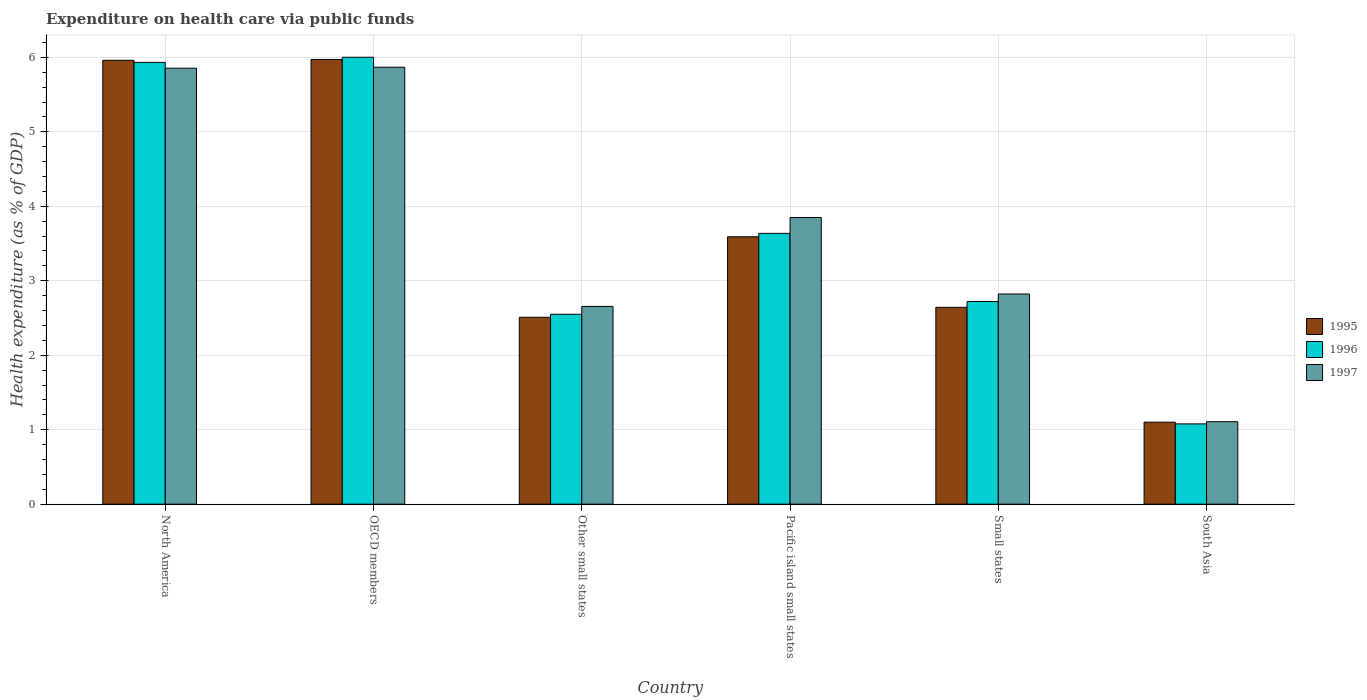How many different coloured bars are there?
Ensure brevity in your answer.  3. How many bars are there on the 3rd tick from the left?
Your response must be concise. 3. How many bars are there on the 5th tick from the right?
Your answer should be very brief. 3. What is the label of the 3rd group of bars from the left?
Give a very brief answer. Other small states. What is the expenditure made on health care in 1996 in OECD members?
Provide a short and direct response. 6. Across all countries, what is the maximum expenditure made on health care in 1996?
Keep it short and to the point. 6. Across all countries, what is the minimum expenditure made on health care in 1996?
Your answer should be compact. 1.08. In which country was the expenditure made on health care in 1997 minimum?
Your answer should be very brief. South Asia. What is the total expenditure made on health care in 1996 in the graph?
Your answer should be compact. 21.92. What is the difference between the expenditure made on health care in 1995 in OECD members and that in Small states?
Provide a succinct answer. 3.33. What is the difference between the expenditure made on health care in 1995 in North America and the expenditure made on health care in 1997 in OECD members?
Keep it short and to the point. 0.09. What is the average expenditure made on health care in 1995 per country?
Offer a very short reply. 3.63. What is the difference between the expenditure made on health care of/in 1997 and expenditure made on health care of/in 1996 in Pacific island small states?
Offer a very short reply. 0.21. What is the ratio of the expenditure made on health care in 1995 in North America to that in South Asia?
Ensure brevity in your answer.  5.41. Is the expenditure made on health care in 1995 in OECD members less than that in Small states?
Make the answer very short. No. What is the difference between the highest and the second highest expenditure made on health care in 1997?
Your answer should be very brief. 2. What is the difference between the highest and the lowest expenditure made on health care in 1997?
Provide a short and direct response. 4.76. Is it the case that in every country, the sum of the expenditure made on health care in 1997 and expenditure made on health care in 1995 is greater than the expenditure made on health care in 1996?
Keep it short and to the point. Yes. How many bars are there?
Give a very brief answer. 18. What is the difference between two consecutive major ticks on the Y-axis?
Keep it short and to the point. 1. How many legend labels are there?
Offer a terse response. 3. How are the legend labels stacked?
Your answer should be compact. Vertical. What is the title of the graph?
Provide a short and direct response. Expenditure on health care via public funds. What is the label or title of the Y-axis?
Offer a terse response. Health expenditure (as % of GDP). What is the Health expenditure (as % of GDP) in 1995 in North America?
Keep it short and to the point. 5.96. What is the Health expenditure (as % of GDP) of 1996 in North America?
Provide a succinct answer. 5.93. What is the Health expenditure (as % of GDP) of 1997 in North America?
Give a very brief answer. 5.85. What is the Health expenditure (as % of GDP) of 1995 in OECD members?
Offer a terse response. 5.97. What is the Health expenditure (as % of GDP) of 1996 in OECD members?
Offer a very short reply. 6. What is the Health expenditure (as % of GDP) in 1997 in OECD members?
Offer a very short reply. 5.87. What is the Health expenditure (as % of GDP) of 1995 in Other small states?
Ensure brevity in your answer.  2.51. What is the Health expenditure (as % of GDP) in 1996 in Other small states?
Make the answer very short. 2.55. What is the Health expenditure (as % of GDP) in 1997 in Other small states?
Offer a terse response. 2.66. What is the Health expenditure (as % of GDP) in 1995 in Pacific island small states?
Your answer should be compact. 3.59. What is the Health expenditure (as % of GDP) in 1996 in Pacific island small states?
Keep it short and to the point. 3.64. What is the Health expenditure (as % of GDP) of 1997 in Pacific island small states?
Give a very brief answer. 3.85. What is the Health expenditure (as % of GDP) in 1995 in Small states?
Give a very brief answer. 2.64. What is the Health expenditure (as % of GDP) in 1996 in Small states?
Make the answer very short. 2.72. What is the Health expenditure (as % of GDP) in 1997 in Small states?
Your answer should be very brief. 2.82. What is the Health expenditure (as % of GDP) in 1995 in South Asia?
Provide a succinct answer. 1.1. What is the Health expenditure (as % of GDP) in 1996 in South Asia?
Keep it short and to the point. 1.08. What is the Health expenditure (as % of GDP) of 1997 in South Asia?
Ensure brevity in your answer.  1.11. Across all countries, what is the maximum Health expenditure (as % of GDP) in 1995?
Make the answer very short. 5.97. Across all countries, what is the maximum Health expenditure (as % of GDP) in 1996?
Give a very brief answer. 6. Across all countries, what is the maximum Health expenditure (as % of GDP) of 1997?
Your response must be concise. 5.87. Across all countries, what is the minimum Health expenditure (as % of GDP) of 1995?
Keep it short and to the point. 1.1. Across all countries, what is the minimum Health expenditure (as % of GDP) of 1996?
Give a very brief answer. 1.08. Across all countries, what is the minimum Health expenditure (as % of GDP) of 1997?
Offer a very short reply. 1.11. What is the total Health expenditure (as % of GDP) of 1995 in the graph?
Your answer should be very brief. 21.78. What is the total Health expenditure (as % of GDP) of 1996 in the graph?
Provide a succinct answer. 21.92. What is the total Health expenditure (as % of GDP) of 1997 in the graph?
Provide a succinct answer. 22.16. What is the difference between the Health expenditure (as % of GDP) in 1995 in North America and that in OECD members?
Make the answer very short. -0.01. What is the difference between the Health expenditure (as % of GDP) of 1996 in North America and that in OECD members?
Provide a succinct answer. -0.07. What is the difference between the Health expenditure (as % of GDP) in 1997 in North America and that in OECD members?
Your response must be concise. -0.01. What is the difference between the Health expenditure (as % of GDP) in 1995 in North America and that in Other small states?
Make the answer very short. 3.45. What is the difference between the Health expenditure (as % of GDP) of 1996 in North America and that in Other small states?
Your answer should be very brief. 3.38. What is the difference between the Health expenditure (as % of GDP) in 1997 in North America and that in Other small states?
Your answer should be compact. 3.2. What is the difference between the Health expenditure (as % of GDP) of 1995 in North America and that in Pacific island small states?
Give a very brief answer. 2.37. What is the difference between the Health expenditure (as % of GDP) of 1996 in North America and that in Pacific island small states?
Your response must be concise. 2.3. What is the difference between the Health expenditure (as % of GDP) of 1997 in North America and that in Pacific island small states?
Offer a very short reply. 2. What is the difference between the Health expenditure (as % of GDP) of 1995 in North America and that in Small states?
Offer a very short reply. 3.32. What is the difference between the Health expenditure (as % of GDP) of 1996 in North America and that in Small states?
Offer a very short reply. 3.21. What is the difference between the Health expenditure (as % of GDP) of 1997 in North America and that in Small states?
Give a very brief answer. 3.03. What is the difference between the Health expenditure (as % of GDP) in 1995 in North America and that in South Asia?
Provide a short and direct response. 4.86. What is the difference between the Health expenditure (as % of GDP) of 1996 in North America and that in South Asia?
Provide a short and direct response. 4.85. What is the difference between the Health expenditure (as % of GDP) of 1997 in North America and that in South Asia?
Your response must be concise. 4.75. What is the difference between the Health expenditure (as % of GDP) of 1995 in OECD members and that in Other small states?
Offer a terse response. 3.46. What is the difference between the Health expenditure (as % of GDP) in 1996 in OECD members and that in Other small states?
Your response must be concise. 3.45. What is the difference between the Health expenditure (as % of GDP) of 1997 in OECD members and that in Other small states?
Offer a terse response. 3.21. What is the difference between the Health expenditure (as % of GDP) in 1995 in OECD members and that in Pacific island small states?
Your answer should be very brief. 2.38. What is the difference between the Health expenditure (as % of GDP) in 1996 in OECD members and that in Pacific island small states?
Ensure brevity in your answer.  2.37. What is the difference between the Health expenditure (as % of GDP) of 1997 in OECD members and that in Pacific island small states?
Keep it short and to the point. 2.02. What is the difference between the Health expenditure (as % of GDP) in 1995 in OECD members and that in Small states?
Your response must be concise. 3.33. What is the difference between the Health expenditure (as % of GDP) in 1996 in OECD members and that in Small states?
Your answer should be very brief. 3.28. What is the difference between the Health expenditure (as % of GDP) of 1997 in OECD members and that in Small states?
Ensure brevity in your answer.  3.05. What is the difference between the Health expenditure (as % of GDP) of 1995 in OECD members and that in South Asia?
Provide a succinct answer. 4.87. What is the difference between the Health expenditure (as % of GDP) in 1996 in OECD members and that in South Asia?
Offer a terse response. 4.92. What is the difference between the Health expenditure (as % of GDP) of 1997 in OECD members and that in South Asia?
Your response must be concise. 4.76. What is the difference between the Health expenditure (as % of GDP) in 1995 in Other small states and that in Pacific island small states?
Offer a terse response. -1.08. What is the difference between the Health expenditure (as % of GDP) in 1996 in Other small states and that in Pacific island small states?
Your answer should be compact. -1.09. What is the difference between the Health expenditure (as % of GDP) in 1997 in Other small states and that in Pacific island small states?
Offer a very short reply. -1.19. What is the difference between the Health expenditure (as % of GDP) in 1995 in Other small states and that in Small states?
Your answer should be very brief. -0.13. What is the difference between the Health expenditure (as % of GDP) in 1996 in Other small states and that in Small states?
Offer a terse response. -0.17. What is the difference between the Health expenditure (as % of GDP) in 1997 in Other small states and that in Small states?
Keep it short and to the point. -0.17. What is the difference between the Health expenditure (as % of GDP) in 1995 in Other small states and that in South Asia?
Your answer should be very brief. 1.41. What is the difference between the Health expenditure (as % of GDP) in 1996 in Other small states and that in South Asia?
Offer a very short reply. 1.47. What is the difference between the Health expenditure (as % of GDP) of 1997 in Other small states and that in South Asia?
Offer a terse response. 1.55. What is the difference between the Health expenditure (as % of GDP) in 1995 in Pacific island small states and that in Small states?
Your answer should be very brief. 0.95. What is the difference between the Health expenditure (as % of GDP) of 1996 in Pacific island small states and that in Small states?
Offer a very short reply. 0.92. What is the difference between the Health expenditure (as % of GDP) of 1997 in Pacific island small states and that in Small states?
Your response must be concise. 1.03. What is the difference between the Health expenditure (as % of GDP) in 1995 in Pacific island small states and that in South Asia?
Your answer should be compact. 2.49. What is the difference between the Health expenditure (as % of GDP) in 1996 in Pacific island small states and that in South Asia?
Your answer should be compact. 2.56. What is the difference between the Health expenditure (as % of GDP) of 1997 in Pacific island small states and that in South Asia?
Offer a very short reply. 2.74. What is the difference between the Health expenditure (as % of GDP) in 1995 in Small states and that in South Asia?
Your answer should be very brief. 1.54. What is the difference between the Health expenditure (as % of GDP) in 1996 in Small states and that in South Asia?
Offer a very short reply. 1.64. What is the difference between the Health expenditure (as % of GDP) in 1997 in Small states and that in South Asia?
Make the answer very short. 1.71. What is the difference between the Health expenditure (as % of GDP) in 1995 in North America and the Health expenditure (as % of GDP) in 1996 in OECD members?
Your response must be concise. -0.04. What is the difference between the Health expenditure (as % of GDP) of 1995 in North America and the Health expenditure (as % of GDP) of 1997 in OECD members?
Your response must be concise. 0.09. What is the difference between the Health expenditure (as % of GDP) of 1996 in North America and the Health expenditure (as % of GDP) of 1997 in OECD members?
Offer a terse response. 0.06. What is the difference between the Health expenditure (as % of GDP) of 1995 in North America and the Health expenditure (as % of GDP) of 1996 in Other small states?
Offer a very short reply. 3.41. What is the difference between the Health expenditure (as % of GDP) in 1995 in North America and the Health expenditure (as % of GDP) in 1997 in Other small states?
Your answer should be compact. 3.31. What is the difference between the Health expenditure (as % of GDP) in 1996 in North America and the Health expenditure (as % of GDP) in 1997 in Other small states?
Give a very brief answer. 3.28. What is the difference between the Health expenditure (as % of GDP) of 1995 in North America and the Health expenditure (as % of GDP) of 1996 in Pacific island small states?
Provide a succinct answer. 2.32. What is the difference between the Health expenditure (as % of GDP) in 1995 in North America and the Health expenditure (as % of GDP) in 1997 in Pacific island small states?
Give a very brief answer. 2.11. What is the difference between the Health expenditure (as % of GDP) of 1996 in North America and the Health expenditure (as % of GDP) of 1997 in Pacific island small states?
Offer a very short reply. 2.08. What is the difference between the Health expenditure (as % of GDP) of 1995 in North America and the Health expenditure (as % of GDP) of 1996 in Small states?
Offer a very short reply. 3.24. What is the difference between the Health expenditure (as % of GDP) of 1995 in North America and the Health expenditure (as % of GDP) of 1997 in Small states?
Offer a very short reply. 3.14. What is the difference between the Health expenditure (as % of GDP) of 1996 in North America and the Health expenditure (as % of GDP) of 1997 in Small states?
Your answer should be very brief. 3.11. What is the difference between the Health expenditure (as % of GDP) of 1995 in North America and the Health expenditure (as % of GDP) of 1996 in South Asia?
Your answer should be very brief. 4.88. What is the difference between the Health expenditure (as % of GDP) in 1995 in North America and the Health expenditure (as % of GDP) in 1997 in South Asia?
Provide a short and direct response. 4.85. What is the difference between the Health expenditure (as % of GDP) in 1996 in North America and the Health expenditure (as % of GDP) in 1997 in South Asia?
Keep it short and to the point. 4.83. What is the difference between the Health expenditure (as % of GDP) of 1995 in OECD members and the Health expenditure (as % of GDP) of 1996 in Other small states?
Your answer should be compact. 3.42. What is the difference between the Health expenditure (as % of GDP) of 1995 in OECD members and the Health expenditure (as % of GDP) of 1997 in Other small states?
Your response must be concise. 3.32. What is the difference between the Health expenditure (as % of GDP) in 1996 in OECD members and the Health expenditure (as % of GDP) in 1997 in Other small states?
Your answer should be compact. 3.35. What is the difference between the Health expenditure (as % of GDP) of 1995 in OECD members and the Health expenditure (as % of GDP) of 1996 in Pacific island small states?
Your response must be concise. 2.34. What is the difference between the Health expenditure (as % of GDP) of 1995 in OECD members and the Health expenditure (as % of GDP) of 1997 in Pacific island small states?
Your response must be concise. 2.12. What is the difference between the Health expenditure (as % of GDP) of 1996 in OECD members and the Health expenditure (as % of GDP) of 1997 in Pacific island small states?
Provide a succinct answer. 2.15. What is the difference between the Health expenditure (as % of GDP) of 1995 in OECD members and the Health expenditure (as % of GDP) of 1996 in Small states?
Your answer should be compact. 3.25. What is the difference between the Health expenditure (as % of GDP) in 1995 in OECD members and the Health expenditure (as % of GDP) in 1997 in Small states?
Make the answer very short. 3.15. What is the difference between the Health expenditure (as % of GDP) in 1996 in OECD members and the Health expenditure (as % of GDP) in 1997 in Small states?
Your answer should be very brief. 3.18. What is the difference between the Health expenditure (as % of GDP) of 1995 in OECD members and the Health expenditure (as % of GDP) of 1996 in South Asia?
Offer a terse response. 4.89. What is the difference between the Health expenditure (as % of GDP) of 1995 in OECD members and the Health expenditure (as % of GDP) of 1997 in South Asia?
Provide a short and direct response. 4.86. What is the difference between the Health expenditure (as % of GDP) of 1996 in OECD members and the Health expenditure (as % of GDP) of 1997 in South Asia?
Keep it short and to the point. 4.89. What is the difference between the Health expenditure (as % of GDP) in 1995 in Other small states and the Health expenditure (as % of GDP) in 1996 in Pacific island small states?
Offer a terse response. -1.13. What is the difference between the Health expenditure (as % of GDP) in 1995 in Other small states and the Health expenditure (as % of GDP) in 1997 in Pacific island small states?
Offer a very short reply. -1.34. What is the difference between the Health expenditure (as % of GDP) of 1996 in Other small states and the Health expenditure (as % of GDP) of 1997 in Pacific island small states?
Provide a short and direct response. -1.3. What is the difference between the Health expenditure (as % of GDP) of 1995 in Other small states and the Health expenditure (as % of GDP) of 1996 in Small states?
Your answer should be compact. -0.21. What is the difference between the Health expenditure (as % of GDP) in 1995 in Other small states and the Health expenditure (as % of GDP) in 1997 in Small states?
Offer a very short reply. -0.31. What is the difference between the Health expenditure (as % of GDP) in 1996 in Other small states and the Health expenditure (as % of GDP) in 1997 in Small states?
Your answer should be very brief. -0.27. What is the difference between the Health expenditure (as % of GDP) of 1995 in Other small states and the Health expenditure (as % of GDP) of 1996 in South Asia?
Your response must be concise. 1.43. What is the difference between the Health expenditure (as % of GDP) of 1995 in Other small states and the Health expenditure (as % of GDP) of 1997 in South Asia?
Provide a short and direct response. 1.4. What is the difference between the Health expenditure (as % of GDP) of 1996 in Other small states and the Health expenditure (as % of GDP) of 1997 in South Asia?
Your response must be concise. 1.44. What is the difference between the Health expenditure (as % of GDP) in 1995 in Pacific island small states and the Health expenditure (as % of GDP) in 1996 in Small states?
Keep it short and to the point. 0.87. What is the difference between the Health expenditure (as % of GDP) of 1995 in Pacific island small states and the Health expenditure (as % of GDP) of 1997 in Small states?
Give a very brief answer. 0.77. What is the difference between the Health expenditure (as % of GDP) of 1996 in Pacific island small states and the Health expenditure (as % of GDP) of 1997 in Small states?
Your answer should be compact. 0.81. What is the difference between the Health expenditure (as % of GDP) in 1995 in Pacific island small states and the Health expenditure (as % of GDP) in 1996 in South Asia?
Provide a short and direct response. 2.51. What is the difference between the Health expenditure (as % of GDP) in 1995 in Pacific island small states and the Health expenditure (as % of GDP) in 1997 in South Asia?
Your answer should be very brief. 2.48. What is the difference between the Health expenditure (as % of GDP) of 1996 in Pacific island small states and the Health expenditure (as % of GDP) of 1997 in South Asia?
Offer a terse response. 2.53. What is the difference between the Health expenditure (as % of GDP) in 1995 in Small states and the Health expenditure (as % of GDP) in 1996 in South Asia?
Provide a succinct answer. 1.57. What is the difference between the Health expenditure (as % of GDP) in 1995 in Small states and the Health expenditure (as % of GDP) in 1997 in South Asia?
Your answer should be very brief. 1.54. What is the difference between the Health expenditure (as % of GDP) of 1996 in Small states and the Health expenditure (as % of GDP) of 1997 in South Asia?
Ensure brevity in your answer.  1.61. What is the average Health expenditure (as % of GDP) of 1995 per country?
Provide a succinct answer. 3.63. What is the average Health expenditure (as % of GDP) of 1996 per country?
Give a very brief answer. 3.65. What is the average Health expenditure (as % of GDP) of 1997 per country?
Provide a succinct answer. 3.69. What is the difference between the Health expenditure (as % of GDP) in 1995 and Health expenditure (as % of GDP) in 1996 in North America?
Provide a short and direct response. 0.03. What is the difference between the Health expenditure (as % of GDP) in 1995 and Health expenditure (as % of GDP) in 1997 in North America?
Provide a succinct answer. 0.11. What is the difference between the Health expenditure (as % of GDP) of 1996 and Health expenditure (as % of GDP) of 1997 in North America?
Give a very brief answer. 0.08. What is the difference between the Health expenditure (as % of GDP) of 1995 and Health expenditure (as % of GDP) of 1996 in OECD members?
Your answer should be very brief. -0.03. What is the difference between the Health expenditure (as % of GDP) in 1995 and Health expenditure (as % of GDP) in 1997 in OECD members?
Ensure brevity in your answer.  0.1. What is the difference between the Health expenditure (as % of GDP) of 1996 and Health expenditure (as % of GDP) of 1997 in OECD members?
Keep it short and to the point. 0.13. What is the difference between the Health expenditure (as % of GDP) in 1995 and Health expenditure (as % of GDP) in 1996 in Other small states?
Your answer should be very brief. -0.04. What is the difference between the Health expenditure (as % of GDP) of 1995 and Health expenditure (as % of GDP) of 1997 in Other small states?
Your answer should be compact. -0.15. What is the difference between the Health expenditure (as % of GDP) of 1996 and Health expenditure (as % of GDP) of 1997 in Other small states?
Provide a short and direct response. -0.11. What is the difference between the Health expenditure (as % of GDP) of 1995 and Health expenditure (as % of GDP) of 1996 in Pacific island small states?
Your answer should be compact. -0.05. What is the difference between the Health expenditure (as % of GDP) in 1995 and Health expenditure (as % of GDP) in 1997 in Pacific island small states?
Provide a succinct answer. -0.26. What is the difference between the Health expenditure (as % of GDP) in 1996 and Health expenditure (as % of GDP) in 1997 in Pacific island small states?
Ensure brevity in your answer.  -0.21. What is the difference between the Health expenditure (as % of GDP) in 1995 and Health expenditure (as % of GDP) in 1996 in Small states?
Ensure brevity in your answer.  -0.08. What is the difference between the Health expenditure (as % of GDP) in 1995 and Health expenditure (as % of GDP) in 1997 in Small states?
Your answer should be compact. -0.18. What is the difference between the Health expenditure (as % of GDP) in 1996 and Health expenditure (as % of GDP) in 1997 in Small states?
Ensure brevity in your answer.  -0.1. What is the difference between the Health expenditure (as % of GDP) in 1995 and Health expenditure (as % of GDP) in 1996 in South Asia?
Your answer should be compact. 0.02. What is the difference between the Health expenditure (as % of GDP) of 1995 and Health expenditure (as % of GDP) of 1997 in South Asia?
Keep it short and to the point. -0.01. What is the difference between the Health expenditure (as % of GDP) in 1996 and Health expenditure (as % of GDP) in 1997 in South Asia?
Give a very brief answer. -0.03. What is the ratio of the Health expenditure (as % of GDP) of 1996 in North America to that in OECD members?
Your answer should be very brief. 0.99. What is the ratio of the Health expenditure (as % of GDP) in 1997 in North America to that in OECD members?
Offer a very short reply. 1. What is the ratio of the Health expenditure (as % of GDP) in 1995 in North America to that in Other small states?
Make the answer very short. 2.38. What is the ratio of the Health expenditure (as % of GDP) in 1996 in North America to that in Other small states?
Give a very brief answer. 2.33. What is the ratio of the Health expenditure (as % of GDP) in 1997 in North America to that in Other small states?
Provide a succinct answer. 2.2. What is the ratio of the Health expenditure (as % of GDP) in 1995 in North America to that in Pacific island small states?
Provide a succinct answer. 1.66. What is the ratio of the Health expenditure (as % of GDP) in 1996 in North America to that in Pacific island small states?
Provide a short and direct response. 1.63. What is the ratio of the Health expenditure (as % of GDP) in 1997 in North America to that in Pacific island small states?
Keep it short and to the point. 1.52. What is the ratio of the Health expenditure (as % of GDP) of 1995 in North America to that in Small states?
Provide a succinct answer. 2.26. What is the ratio of the Health expenditure (as % of GDP) of 1996 in North America to that in Small states?
Offer a very short reply. 2.18. What is the ratio of the Health expenditure (as % of GDP) of 1997 in North America to that in Small states?
Provide a short and direct response. 2.07. What is the ratio of the Health expenditure (as % of GDP) in 1995 in North America to that in South Asia?
Your answer should be compact. 5.41. What is the ratio of the Health expenditure (as % of GDP) of 1996 in North America to that in South Asia?
Offer a very short reply. 5.5. What is the ratio of the Health expenditure (as % of GDP) of 1997 in North America to that in South Asia?
Provide a succinct answer. 5.29. What is the ratio of the Health expenditure (as % of GDP) in 1995 in OECD members to that in Other small states?
Keep it short and to the point. 2.38. What is the ratio of the Health expenditure (as % of GDP) of 1996 in OECD members to that in Other small states?
Your answer should be compact. 2.35. What is the ratio of the Health expenditure (as % of GDP) in 1997 in OECD members to that in Other small states?
Your answer should be very brief. 2.21. What is the ratio of the Health expenditure (as % of GDP) of 1995 in OECD members to that in Pacific island small states?
Offer a very short reply. 1.66. What is the ratio of the Health expenditure (as % of GDP) of 1996 in OECD members to that in Pacific island small states?
Ensure brevity in your answer.  1.65. What is the ratio of the Health expenditure (as % of GDP) of 1997 in OECD members to that in Pacific island small states?
Provide a short and direct response. 1.52. What is the ratio of the Health expenditure (as % of GDP) in 1995 in OECD members to that in Small states?
Offer a very short reply. 2.26. What is the ratio of the Health expenditure (as % of GDP) in 1996 in OECD members to that in Small states?
Ensure brevity in your answer.  2.21. What is the ratio of the Health expenditure (as % of GDP) in 1997 in OECD members to that in Small states?
Your response must be concise. 2.08. What is the ratio of the Health expenditure (as % of GDP) in 1995 in OECD members to that in South Asia?
Provide a short and direct response. 5.42. What is the ratio of the Health expenditure (as % of GDP) in 1996 in OECD members to that in South Asia?
Provide a short and direct response. 5.57. What is the ratio of the Health expenditure (as % of GDP) of 1997 in OECD members to that in South Asia?
Ensure brevity in your answer.  5.3. What is the ratio of the Health expenditure (as % of GDP) of 1995 in Other small states to that in Pacific island small states?
Your response must be concise. 0.7. What is the ratio of the Health expenditure (as % of GDP) in 1996 in Other small states to that in Pacific island small states?
Your answer should be very brief. 0.7. What is the ratio of the Health expenditure (as % of GDP) in 1997 in Other small states to that in Pacific island small states?
Keep it short and to the point. 0.69. What is the ratio of the Health expenditure (as % of GDP) in 1995 in Other small states to that in Small states?
Your response must be concise. 0.95. What is the ratio of the Health expenditure (as % of GDP) in 1996 in Other small states to that in Small states?
Offer a terse response. 0.94. What is the ratio of the Health expenditure (as % of GDP) of 1997 in Other small states to that in Small states?
Keep it short and to the point. 0.94. What is the ratio of the Health expenditure (as % of GDP) in 1995 in Other small states to that in South Asia?
Make the answer very short. 2.28. What is the ratio of the Health expenditure (as % of GDP) of 1996 in Other small states to that in South Asia?
Keep it short and to the point. 2.37. What is the ratio of the Health expenditure (as % of GDP) in 1997 in Other small states to that in South Asia?
Provide a succinct answer. 2.4. What is the ratio of the Health expenditure (as % of GDP) of 1995 in Pacific island small states to that in Small states?
Offer a very short reply. 1.36. What is the ratio of the Health expenditure (as % of GDP) of 1996 in Pacific island small states to that in Small states?
Provide a short and direct response. 1.34. What is the ratio of the Health expenditure (as % of GDP) of 1997 in Pacific island small states to that in Small states?
Your answer should be compact. 1.36. What is the ratio of the Health expenditure (as % of GDP) of 1995 in Pacific island small states to that in South Asia?
Make the answer very short. 3.26. What is the ratio of the Health expenditure (as % of GDP) of 1996 in Pacific island small states to that in South Asia?
Keep it short and to the point. 3.37. What is the ratio of the Health expenditure (as % of GDP) in 1997 in Pacific island small states to that in South Asia?
Your response must be concise. 3.48. What is the ratio of the Health expenditure (as % of GDP) of 1995 in Small states to that in South Asia?
Offer a very short reply. 2.4. What is the ratio of the Health expenditure (as % of GDP) in 1996 in Small states to that in South Asia?
Offer a terse response. 2.52. What is the ratio of the Health expenditure (as % of GDP) of 1997 in Small states to that in South Asia?
Provide a short and direct response. 2.55. What is the difference between the highest and the second highest Health expenditure (as % of GDP) in 1995?
Give a very brief answer. 0.01. What is the difference between the highest and the second highest Health expenditure (as % of GDP) of 1996?
Make the answer very short. 0.07. What is the difference between the highest and the second highest Health expenditure (as % of GDP) of 1997?
Offer a very short reply. 0.01. What is the difference between the highest and the lowest Health expenditure (as % of GDP) in 1995?
Offer a very short reply. 4.87. What is the difference between the highest and the lowest Health expenditure (as % of GDP) in 1996?
Your response must be concise. 4.92. What is the difference between the highest and the lowest Health expenditure (as % of GDP) of 1997?
Provide a short and direct response. 4.76. 